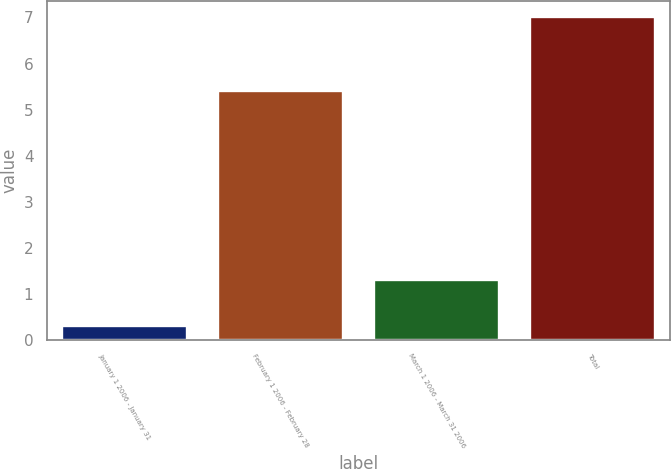Convert chart to OTSL. <chart><loc_0><loc_0><loc_500><loc_500><bar_chart><fcel>January 1 2006 - January 31<fcel>February 1 2006 - February 28<fcel>March 1 2006 - March 31 2006<fcel>Total<nl><fcel>0.3<fcel>5.4<fcel>1.3<fcel>7<nl></chart> 